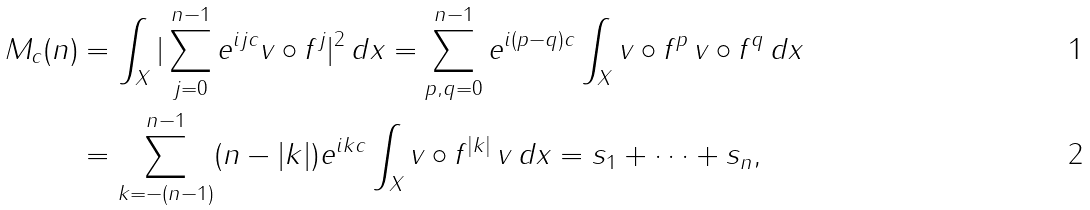Convert formula to latex. <formula><loc_0><loc_0><loc_500><loc_500>M _ { c } ( n ) & = \int _ { X } | \sum _ { j = 0 } ^ { n - 1 } e ^ { i j c } v \circ f ^ { j } | ^ { 2 } \, d x = \sum _ { p , q = 0 } ^ { n - 1 } e ^ { i ( p - q ) c } \int _ { X } v \circ f ^ { p } \, v \circ f ^ { q } \, d x \\ & = \sum _ { k = - ( n - 1 ) } ^ { n - 1 } ( n - | k | ) e ^ { i k c } \int _ { X } v \circ f ^ { | k | } \, v \, d x = s _ { 1 } + \dots + s _ { n } ,</formula> 